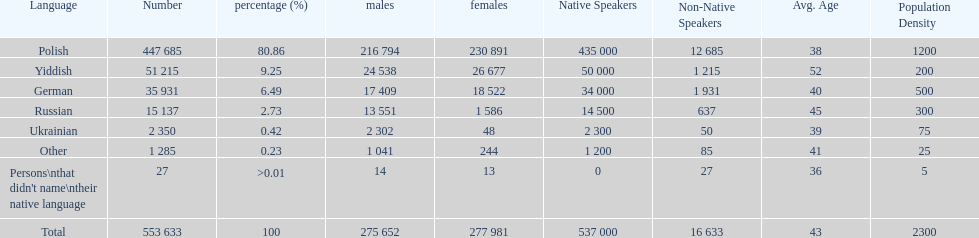Which is the least spoken language? Ukrainian. Give me the full table as a dictionary. {'header': ['Language', 'Number', 'percentage (%)', 'males', 'females', 'Native Speakers', 'Non-Native Speakers', 'Avg. Age', 'Population Density'], 'rows': [['Polish', '447 685', '80.86', '216 794', '230 891', '435 000', '12 685', '38', '1200'], ['Yiddish', '51 215', '9.25', '24 538', '26 677', '50 000', '1 215', '52', '200'], ['German', '35 931', '6.49', '17 409', '18 522', '34 000', '1 931', '40', '500'], ['Russian', '15 137', '2.73', '13 551', '1 586', '14 500', '637', '45', '300'], ['Ukrainian', '2 350', '0.42', '2 302', '48', '2 300', '50', '39', '75'], ['Other', '1 285', '0.23', '1 041', '244', '1 200', '85', '41', '25'], ["Persons\\nthat didn't name\\ntheir native language", '27', '>0.01', '14', '13', '0', '27', '36', '5'], ['Total', '553 633', '100', '275 652', '277 981', '537 000', '16 633', '43', '2300']]} 